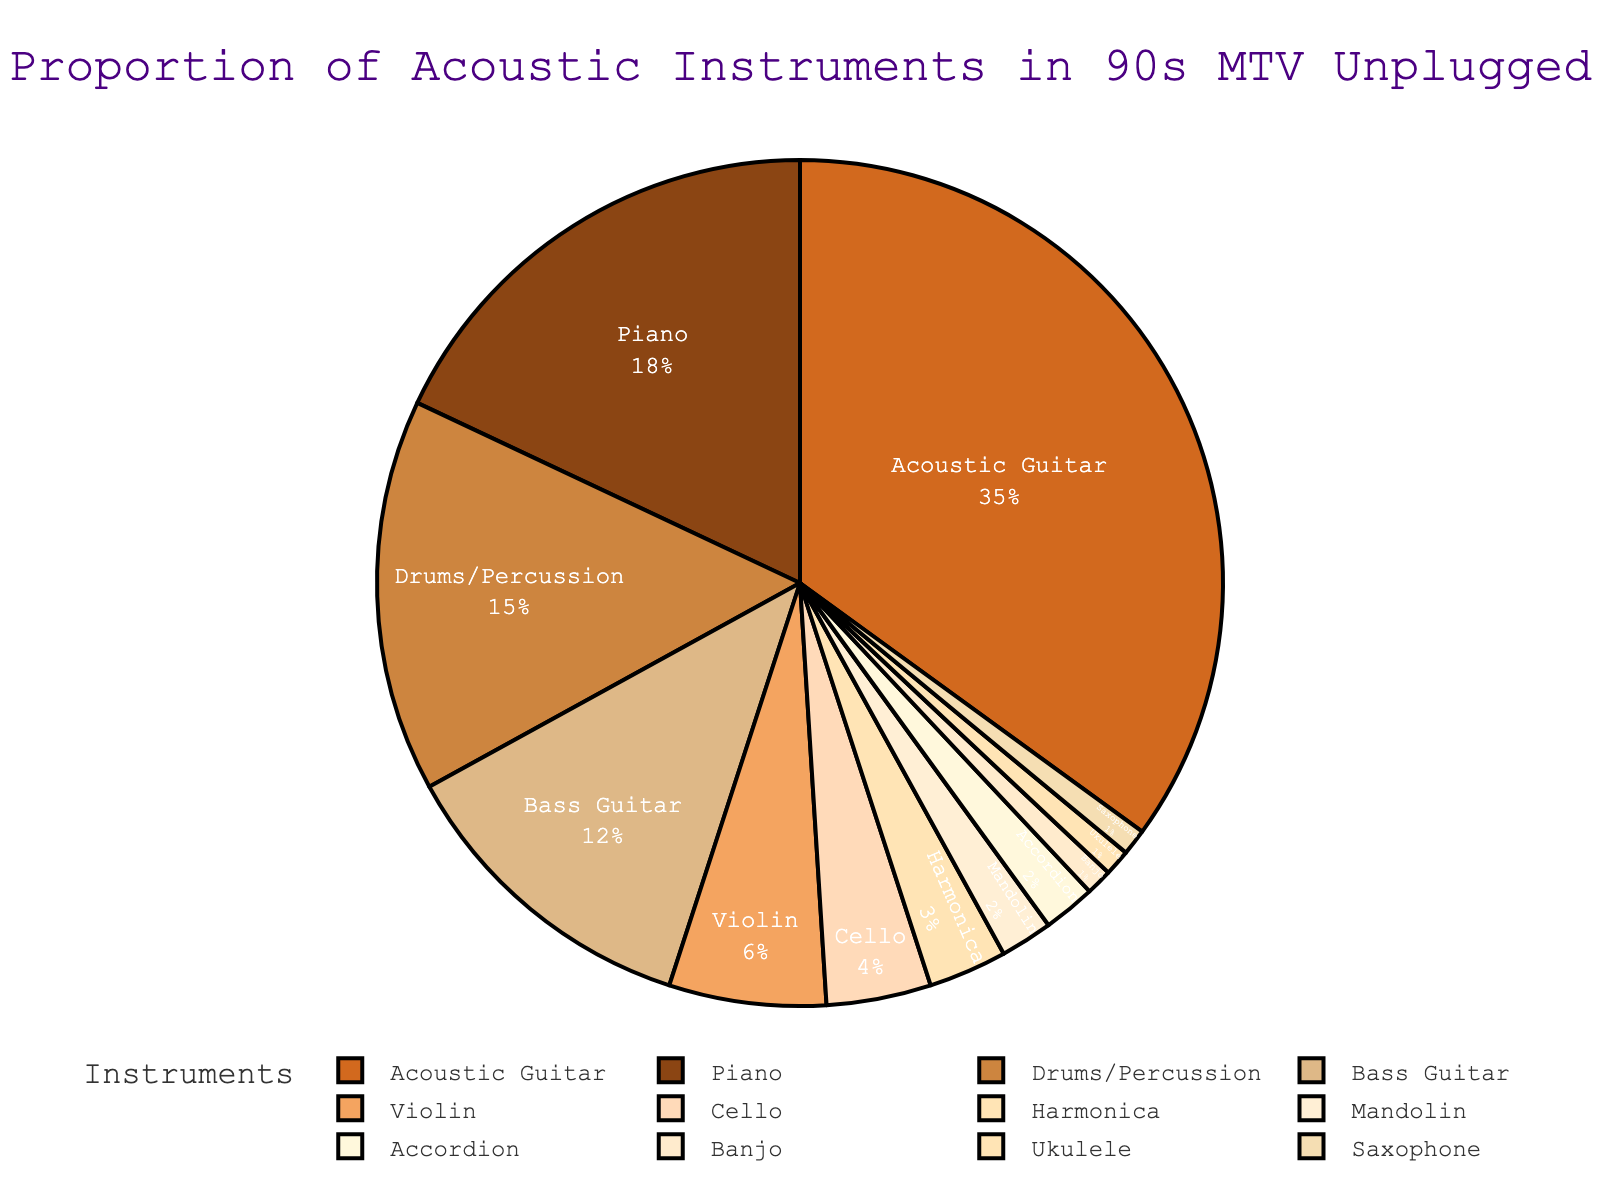What's the most common acoustic instrument used in 90s MTV Unplugged performances? The pie chart shows different acoustic instruments along with their usage percentages. The largest segment represents the most common instrument. The largest segment is the Acoustic Guitar at 35%.
Answer: Acoustic Guitar Which instrument has a slightly higher percentage than bass guitar? First, locate the Bass Guitar segment, which is at 12%. Then, look for the segment that has a percentage slightly higher; Piano is at 18%.
Answer: Piano What's the combined percentage of violin and cello use? Locate the percentages for both Violin (6%) and Cello (4%) on the pie chart. Add these percentages together: 6 + 4 = 10.
Answer: 10% Between mandolin and accordion, which instrument is less common? Locate both the Mandolin (2%) and Accordion (2%) segments on the pie chart. They both have the same percentage, which implies neither is less common than the other.
Answer: Neither, they are the same What is the total percentage occupied by instruments used less than 5% of the time? Identify the segments with less than 5%: Cello (4%), Harmonica (3%), Mandolin (2%), Accordion (2%), Banjo (1%), Ukulele (1%), Saxophone (1%). Sum these values: 4 + 3 + 2 + 2 + 1 + 1 + 1 = 14.
Answer: 14% Which has a greater percentage: drums/percussion or piano? By how much? Locate the segments for Drums/Percussion (15%) and Piano (18%). Piano has a higher percentage. Subtract the smaller percentage from the larger: 18 - 15 = 3.
Answer: Piano by 3% How does the use of bass guitar compare to piano? Locate the segments for Bass Guitar (12%) and Piano (18%). Compare the sizes; Piano has a higher percentage.
Answer: Piano has a higher percentage What percentage more is the use of acoustic guitar compared to the sum of violin and cello? Locate the segments for Acoustic Guitar (35%), Violin (6%), and Cello (4%). Sum Violin and Cello: 6 + 4 = 10. Subtract this sum from the Acoustic Guitar: 35 - 10 = 25.
Answer: 25% What is the least common instrument used and its percentage? Identify the smallest segment in the pie chart, which is the Banjo, Ukulele, and Saxophone all at 1%.
Answer: Banjo, Ukulele, Saxophone at 1% If you combined all instruments used between 1% and 3%, what would be their total percentage? Identify the instruments falling between 1% and 3%: Harmonica (3%), Mandolin (2%), Accordion (2%), Banjo (1%), Ukulele (1%), Saxophone (1%). Sum these percentages: 3 + 2 + 2 + 1 + 1 + 1 = 10.
Answer: 10% 